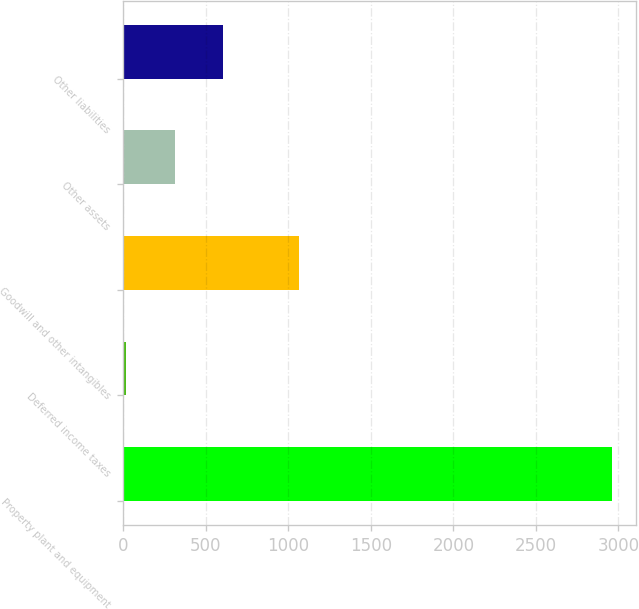<chart> <loc_0><loc_0><loc_500><loc_500><bar_chart><fcel>Property plant and equipment<fcel>Deferred income taxes<fcel>Goodwill and other intangibles<fcel>Other assets<fcel>Other liabilities<nl><fcel>2961<fcel>15<fcel>1066<fcel>309.6<fcel>604.2<nl></chart> 